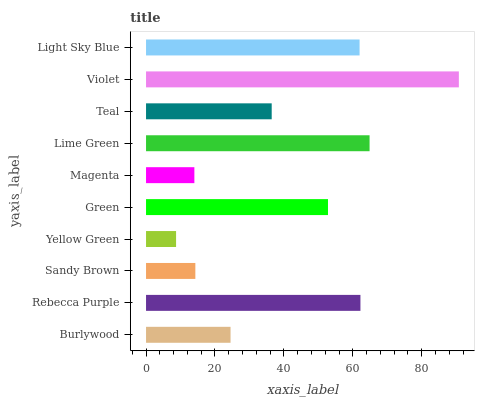Is Yellow Green the minimum?
Answer yes or no. Yes. Is Violet the maximum?
Answer yes or no. Yes. Is Rebecca Purple the minimum?
Answer yes or no. No. Is Rebecca Purple the maximum?
Answer yes or no. No. Is Rebecca Purple greater than Burlywood?
Answer yes or no. Yes. Is Burlywood less than Rebecca Purple?
Answer yes or no. Yes. Is Burlywood greater than Rebecca Purple?
Answer yes or no. No. Is Rebecca Purple less than Burlywood?
Answer yes or no. No. Is Green the high median?
Answer yes or no. Yes. Is Teal the low median?
Answer yes or no. Yes. Is Teal the high median?
Answer yes or no. No. Is Violet the low median?
Answer yes or no. No. 